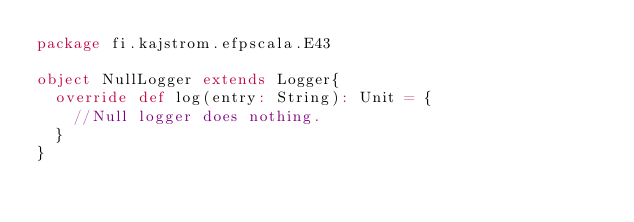<code> <loc_0><loc_0><loc_500><loc_500><_Scala_>package fi.kajstrom.efpscala.E43

object NullLogger extends Logger{
  override def log(entry: String): Unit = {
    //Null logger does nothing.
  }
}
</code> 